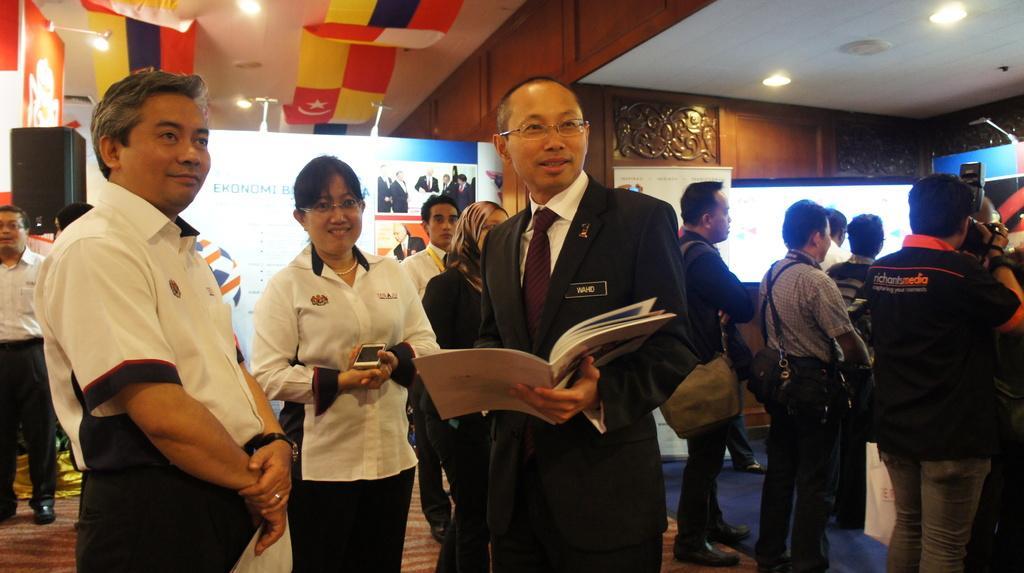In one or two sentences, can you explain what this image depicts? In this image we can see a few people, among them, some people are holding the objects, also we can see a screen, board, speaker and a poster with some text and images, at the top we can see some lights and flags. 